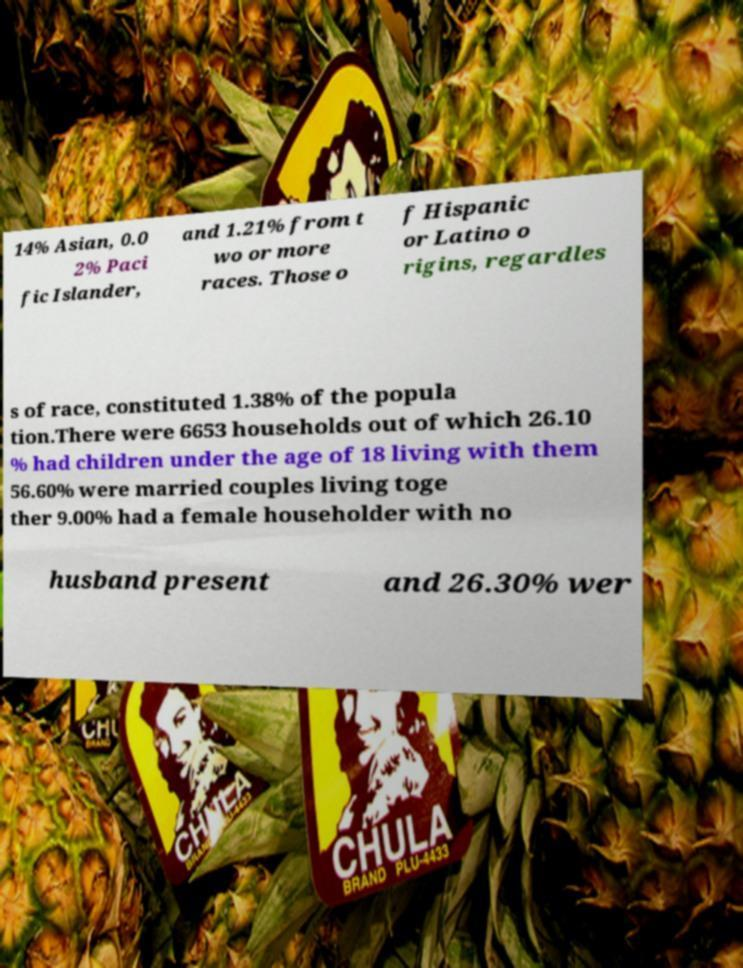I need the written content from this picture converted into text. Can you do that? 14% Asian, 0.0 2% Paci fic Islander, and 1.21% from t wo or more races. Those o f Hispanic or Latino o rigins, regardles s of race, constituted 1.38% of the popula tion.There were 6653 households out of which 26.10 % had children under the age of 18 living with them 56.60% were married couples living toge ther 9.00% had a female householder with no husband present and 26.30% wer 